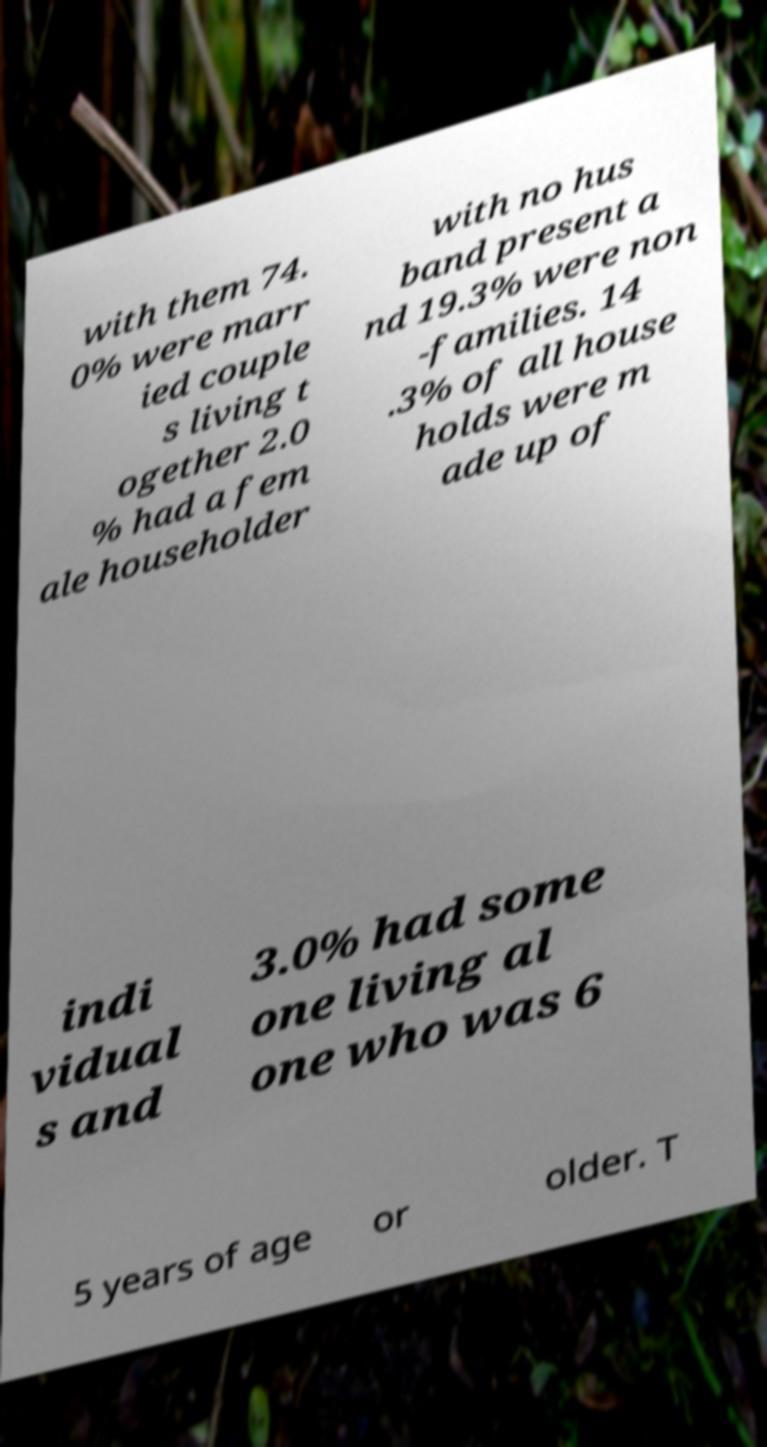Please identify and transcribe the text found in this image. with them 74. 0% were marr ied couple s living t ogether 2.0 % had a fem ale householder with no hus band present a nd 19.3% were non -families. 14 .3% of all house holds were m ade up of indi vidual s and 3.0% had some one living al one who was 6 5 years of age or older. T 